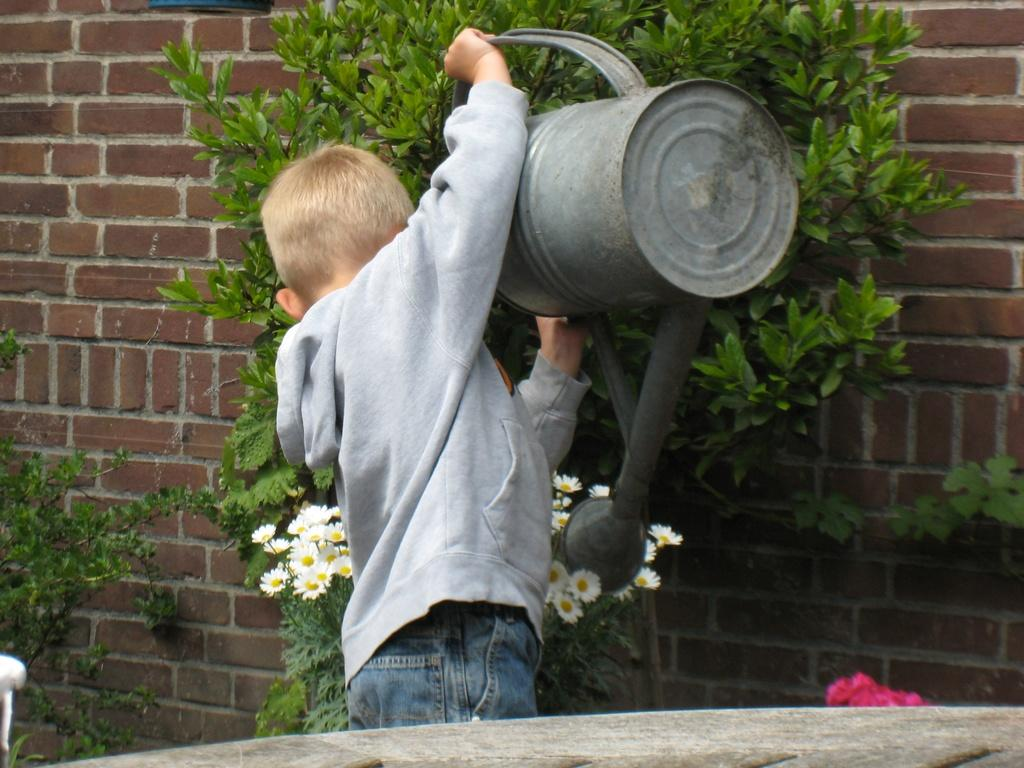Who is the main subject in the image? There is a boy in the image. What is the boy holding in the image? The boy is holding a water can. What is the boy doing with the water can? The boy is watering plants. What type of plants are being watered? The plants have flowers. What can be seen in the background of the image? There is a wall in the background of the image. What type of juice is the boy making in the image? There is no juice or juice-making activity present in the image; the boy is watering plants with a water can. 